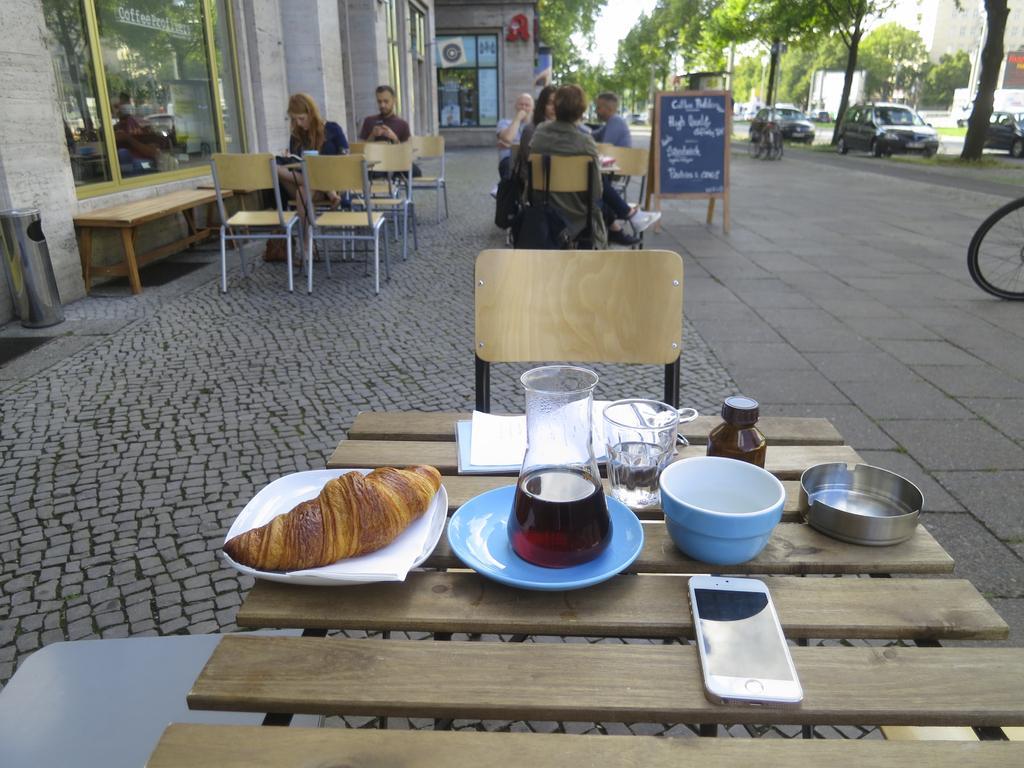Can you describe this image briefly? In this image we can see plate with food, jar, glass, bowl, bottle and mobile phone on the table. We can see this persons are sitting on the chairs near the table. In the background we can see cars, trees and board. 